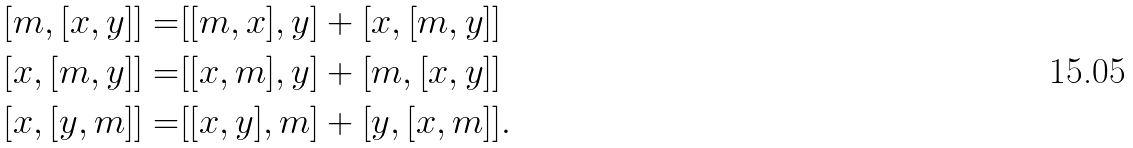Convert formula to latex. <formula><loc_0><loc_0><loc_500><loc_500>[ m , [ x , y ] ] = & [ [ m , x ] , y ] + [ x , [ m , y ] ] \\ [ x , [ m , y ] ] = & [ [ x , m ] , y ] + [ m , [ x , y ] ] \\ [ x , [ y , m ] ] = & [ [ x , y ] , m ] + [ y , [ x , m ] ] .</formula> 